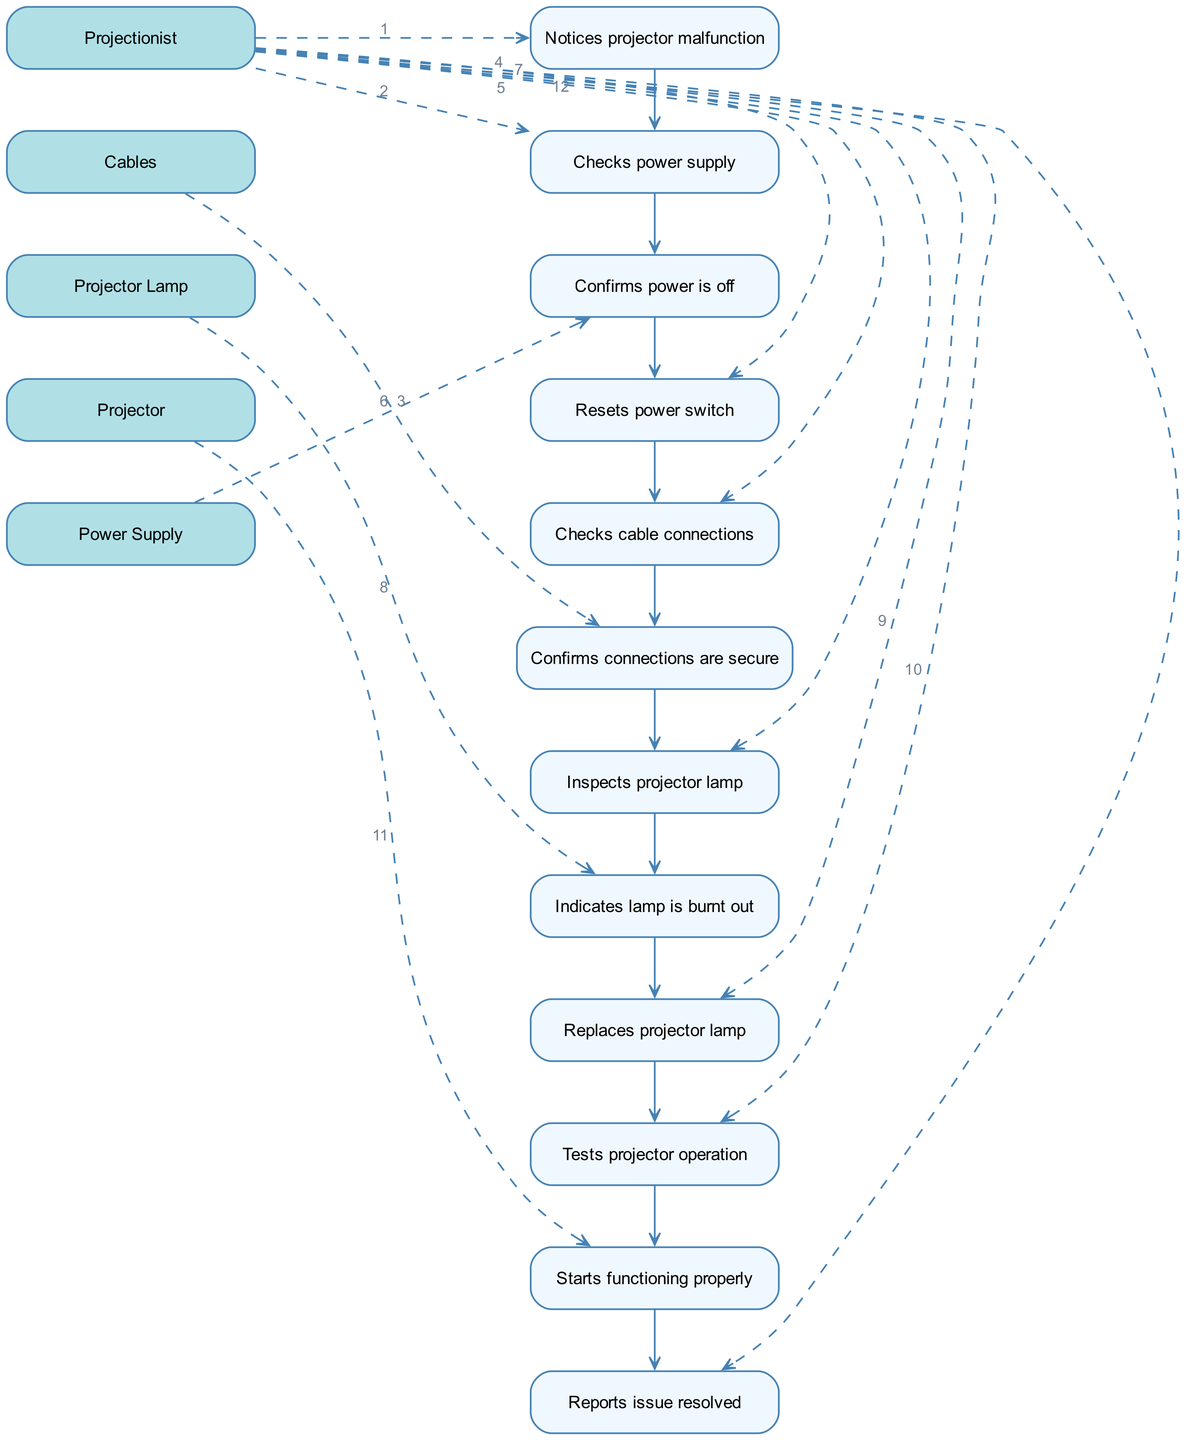What is the first action performed by the Projectionist? According to the diagram, the first action listed under the Projectionist is "Notices projector malfunction". This is the starting point of the sequence.
Answer: Notices projector malfunction How many unique actors are involved in the sequence? By examining the sequence elements, the unique actors identified are the Projectionist, Power Supply, Cables, Projector Lamp, and Projector. There are a total of 5 unique actors.
Answer: 5 What action does the Projector take after the lamp is replaced? The next action following the replacement of the projector lamp is "Tests projector operation", which indicates the sequence of events after replacing the lamp.
Answer: Tests projector operation Which actor confirms that the power is off? The actor that confirms the power is off is the "Power Supply". This occurs immediately after the Projectionist checks the power supply.
Answer: Power Supply Referencing the diagram, after which action is the projector confirmed to be functioning properly? The action that directly precedes the confirmation of the projector functioning properly is "Tests projector operation". After this action, the Projector indicates it has started functioning properly.
Answer: Starts functioning properly What task does the Projectionist perform after inspecting the projector lamp? After inspecting the projector lamp, the next task performed by the Projectionist is "Replaces projector lamp". This action follows the indication that the lamp is burnt out.
Answer: Replaces projector lamp How many actions are performed by the Projectionist throughout the sequence? By counting the actions associated with the Projectionist in the diagram, there are a total of 5 actions: "Notices projector malfunction", "Checks power supply", "Resets power switch", "Checks cable connections", and "Inspects projector lamp". Therefore, the answer is 5.
Answer: 5 What confirmation does the Cables actor provide? The Cables actor confirms "connections are secure". This acknowledgment follows the action of the Projectionist checking the cable connections.
Answer: connections are secure In the sequence, what does the Projectionist report at the end? The final report made by the Projectionist is that the "issue resolved". This indicates the completion of the troubleshooting process for the projector malfunction.
Answer: issue resolved 